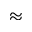Convert formula to latex. <formula><loc_0><loc_0><loc_500><loc_500>\approx</formula> 